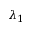<formula> <loc_0><loc_0><loc_500><loc_500>\lambda _ { 1 }</formula> 